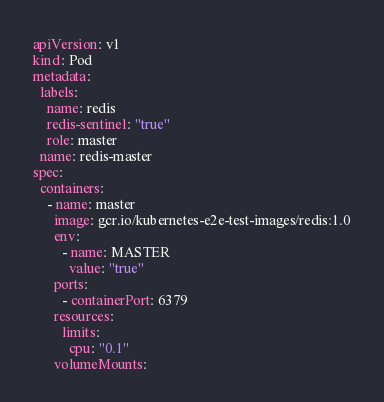Convert code to text. <code><loc_0><loc_0><loc_500><loc_500><_YAML_>apiVersion: v1
kind: Pod
metadata:
  labels:
    name: redis
    redis-sentinel: "true"
    role: master
  name: redis-master
spec:
  containers:
    - name: master
      image: gcr.io/kubernetes-e2e-test-images/redis:1.0
      env:
        - name: MASTER
          value: "true"
      ports:
        - containerPort: 6379
      resources:
        limits:
          cpu: "0.1"
      volumeMounts:</code> 